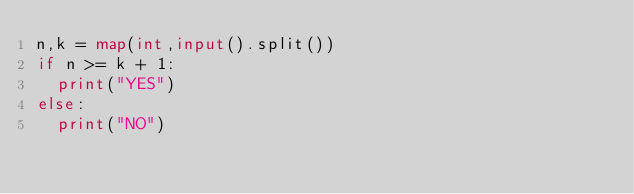Convert code to text. <code><loc_0><loc_0><loc_500><loc_500><_Python_>n,k = map(int,input().split())
if n >= k + 1:
  print("YES")
else:
  print("NO")</code> 